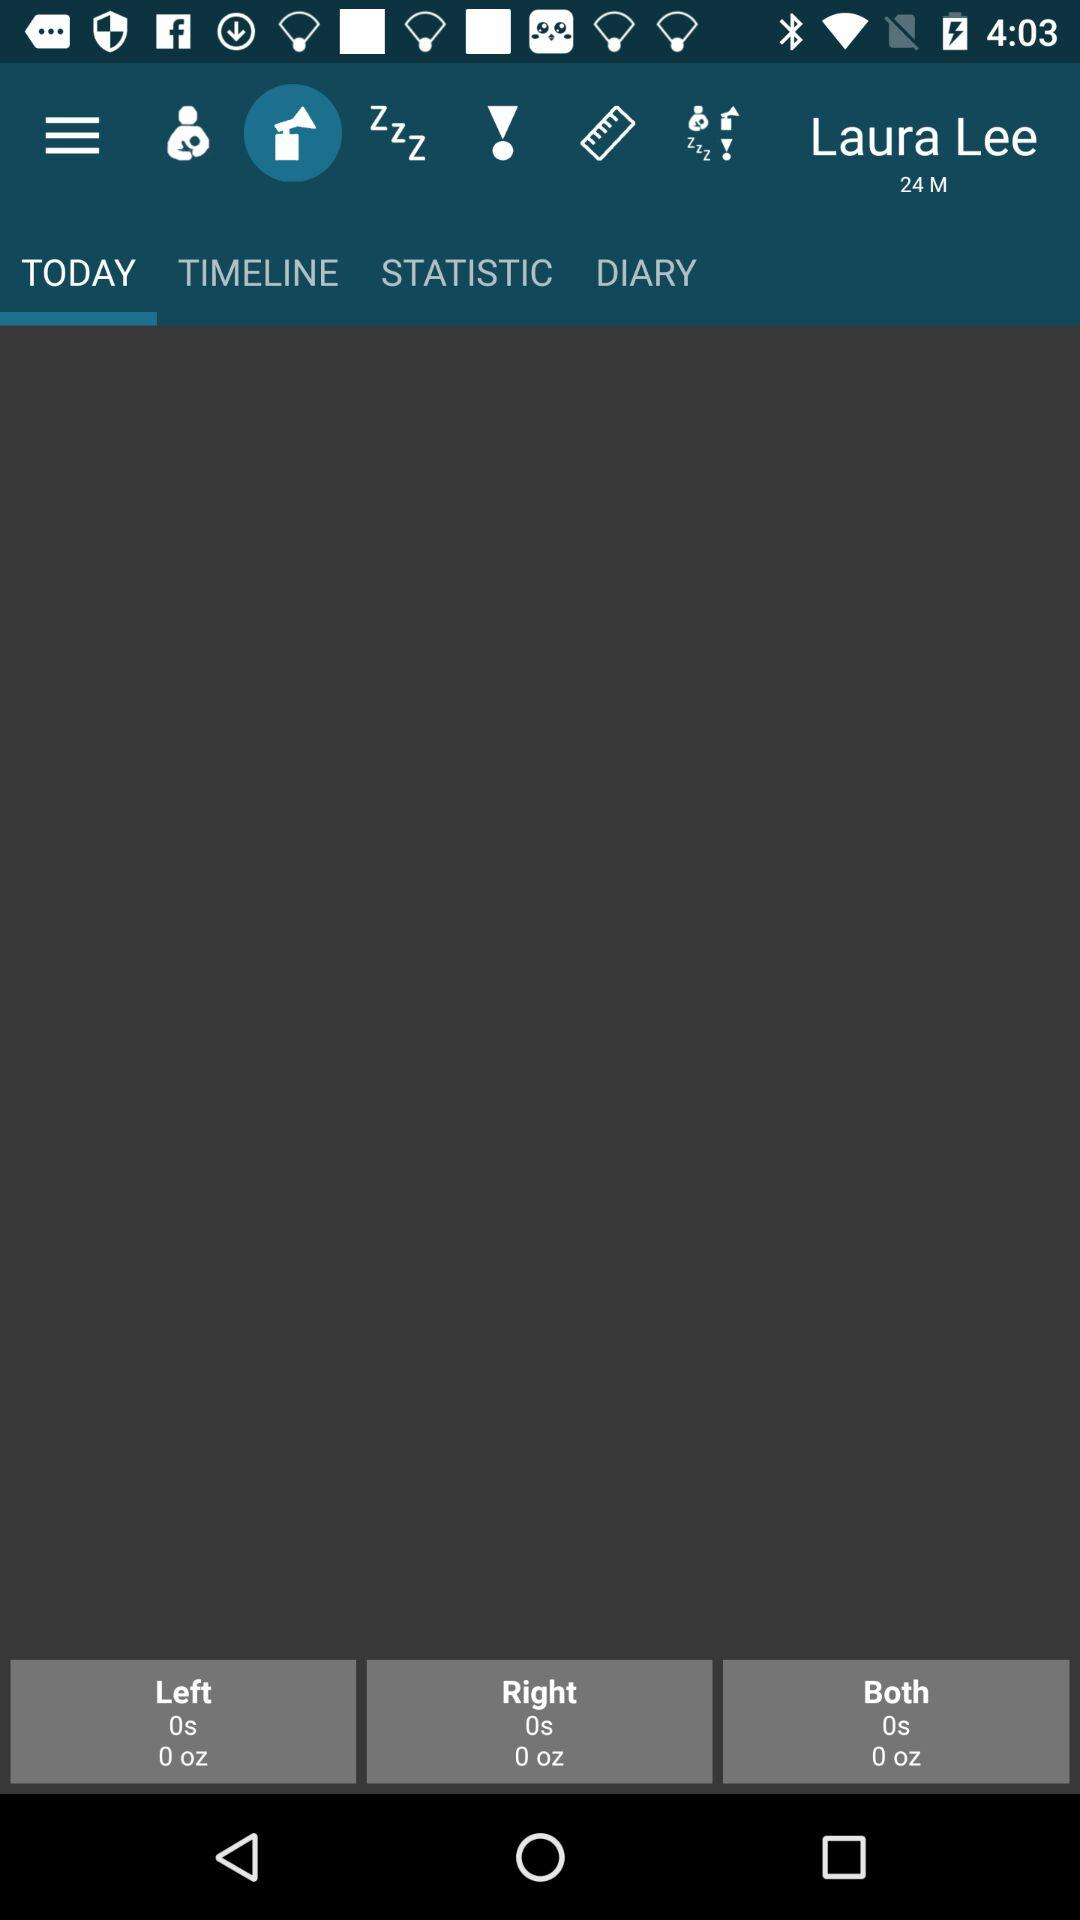What is the shown user name? The shown user name is Laura Lee. 